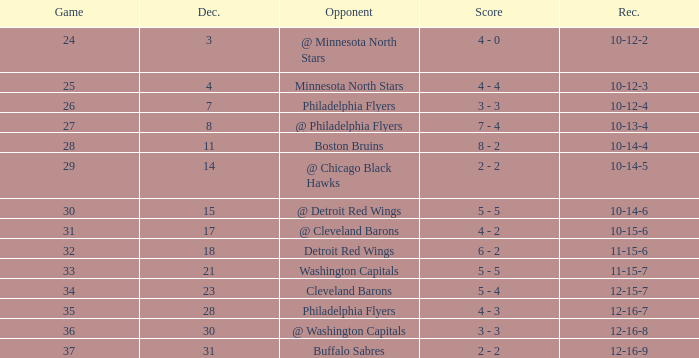What is Opponent, when Game is "37"? Buffalo Sabres. 